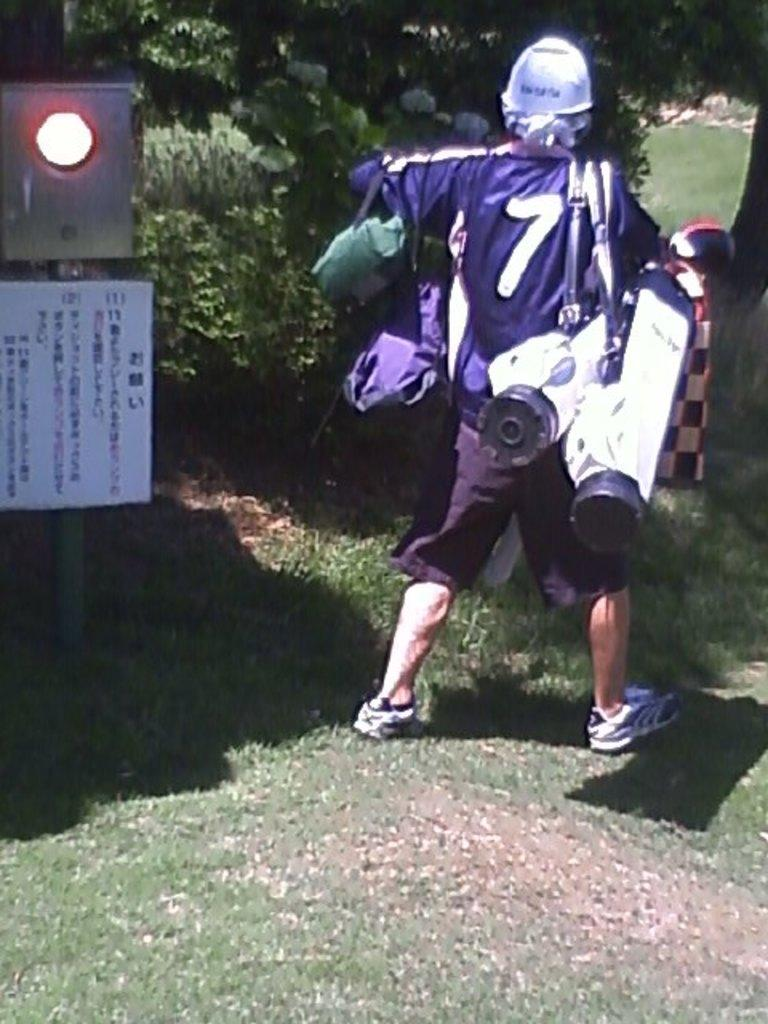What is the person in the image doing? The person is carrying objects in the image. What can be seen beneath the person's feet? The ground is visible in the image, and grass is present on the ground. What type of vegetation is visible in the image? There are plants and trees visible in the image. What is the tall, vertical structure in the image? There is a light pole in the image. What is attached to the light pole? There is a poster attached to the light pole. What can be seen on the ground that is not a part of the ground itself? There are reflections on the ground. What songs can be heard playing in the background of the image? There is no audio or indication of music in the image, so it is not possible to determine what songs might be heard. 